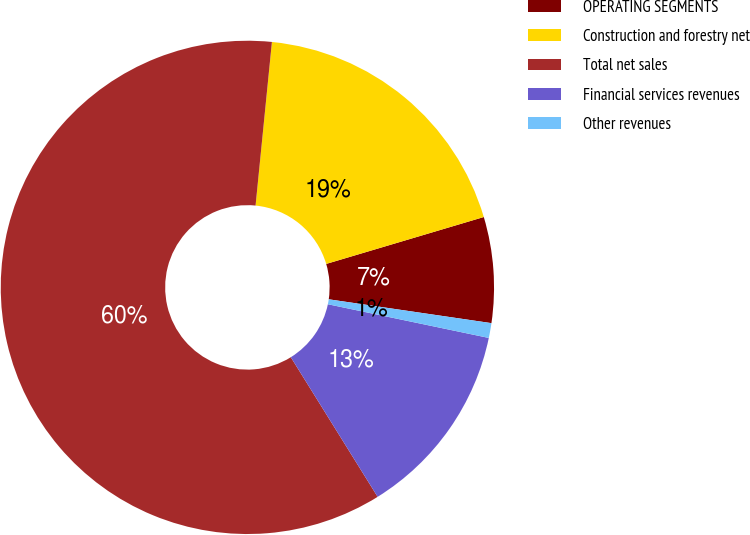<chart> <loc_0><loc_0><loc_500><loc_500><pie_chart><fcel>OPERATING SEGMENTS<fcel>Construction and forestry net<fcel>Total net sales<fcel>Financial services revenues<fcel>Other revenues<nl><fcel>6.92%<fcel>18.81%<fcel>60.44%<fcel>12.86%<fcel>0.97%<nl></chart> 